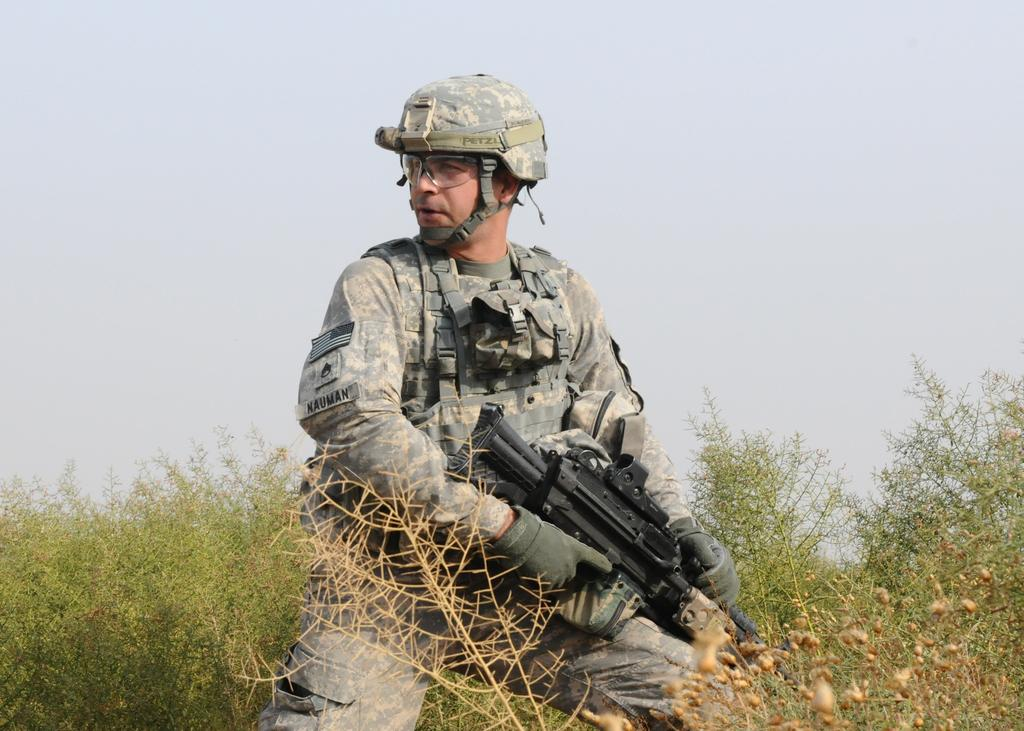Who is present in the image? There is a man in the image. What is the man wearing? The man is wearing an army dress. What is the man holding in the image? The man is holding a gun. What can be seen in the background of the image? There are trees and the sky visible in the background of the image. How many boys are washing their hands in the image? There are no boys or any hand-washing activity present in the image. 